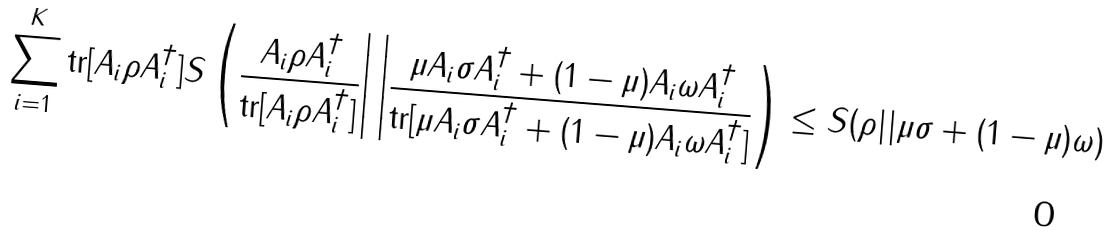Convert formula to latex. <formula><loc_0><loc_0><loc_500><loc_500>\sum _ { i = 1 } ^ { K } \text {tr} [ A _ { i } \rho A _ { i } ^ { \dagger } ] S \left ( \frac { A _ { i } \rho A _ { i } ^ { \dagger } } { \text {tr} [ A _ { i } \rho A _ { i } ^ { \dagger } ] } \right | \left | \frac { \mu A _ { i } \sigma A _ { i } ^ { \dagger } + ( 1 - \mu ) A _ { i } \omega A _ { i } ^ { \dagger } } { \text {tr} [ \mu A _ { i } \sigma A _ { i } ^ { \dagger } + ( 1 - \mu ) A _ { i } \omega A _ { i } ^ { \dagger } ] } \right ) \leq S ( \rho | | \mu \sigma + ( 1 - \mu ) \omega )</formula> 